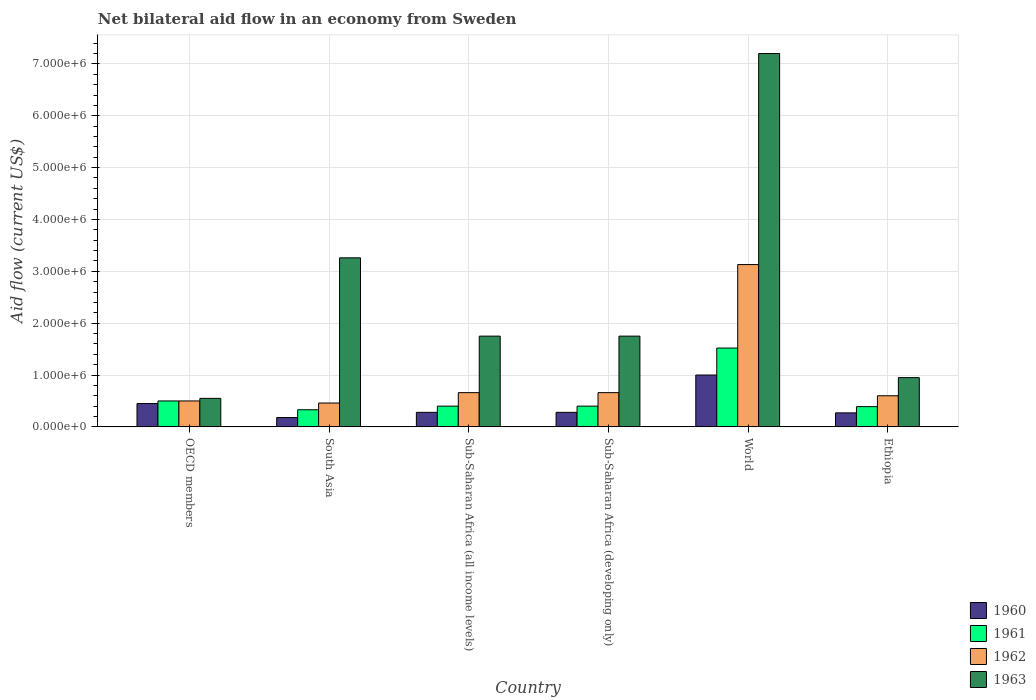How many different coloured bars are there?
Offer a very short reply. 4. How many groups of bars are there?
Your answer should be compact. 6. What is the label of the 6th group of bars from the left?
Offer a terse response. Ethiopia. In how many cases, is the number of bars for a given country not equal to the number of legend labels?
Provide a succinct answer. 0. Across all countries, what is the maximum net bilateral aid flow in 1961?
Your response must be concise. 1.52e+06. In which country was the net bilateral aid flow in 1961 maximum?
Your answer should be very brief. World. In which country was the net bilateral aid flow in 1963 minimum?
Make the answer very short. OECD members. What is the total net bilateral aid flow in 1962 in the graph?
Provide a succinct answer. 6.01e+06. What is the difference between the net bilateral aid flow in 1963 in Sub-Saharan Africa (all income levels) and that in World?
Offer a very short reply. -5.45e+06. What is the difference between the net bilateral aid flow in 1963 in Sub-Saharan Africa (developing only) and the net bilateral aid flow in 1962 in World?
Offer a terse response. -1.38e+06. What is the difference between the net bilateral aid flow of/in 1963 and net bilateral aid flow of/in 1961 in Sub-Saharan Africa (developing only)?
Your answer should be very brief. 1.35e+06. What is the ratio of the net bilateral aid flow in 1963 in OECD members to that in World?
Your answer should be compact. 0.08. Is the net bilateral aid flow in 1963 in Ethiopia less than that in Sub-Saharan Africa (developing only)?
Keep it short and to the point. Yes. What is the difference between the highest and the second highest net bilateral aid flow in 1963?
Give a very brief answer. 3.94e+06. What is the difference between the highest and the lowest net bilateral aid flow in 1962?
Your answer should be compact. 2.67e+06. In how many countries, is the net bilateral aid flow in 1963 greater than the average net bilateral aid flow in 1963 taken over all countries?
Offer a very short reply. 2. What is the difference between two consecutive major ticks on the Y-axis?
Your answer should be very brief. 1.00e+06. Does the graph contain any zero values?
Your response must be concise. No. Does the graph contain grids?
Offer a terse response. Yes. Where does the legend appear in the graph?
Keep it short and to the point. Bottom right. How are the legend labels stacked?
Keep it short and to the point. Vertical. What is the title of the graph?
Your answer should be compact. Net bilateral aid flow in an economy from Sweden. Does "1966" appear as one of the legend labels in the graph?
Offer a very short reply. No. What is the label or title of the X-axis?
Offer a terse response. Country. What is the label or title of the Y-axis?
Your answer should be compact. Aid flow (current US$). What is the Aid flow (current US$) in 1960 in OECD members?
Your answer should be compact. 4.50e+05. What is the Aid flow (current US$) of 1962 in OECD members?
Make the answer very short. 5.00e+05. What is the Aid flow (current US$) in 1962 in South Asia?
Your answer should be very brief. 4.60e+05. What is the Aid flow (current US$) in 1963 in South Asia?
Your response must be concise. 3.26e+06. What is the Aid flow (current US$) of 1961 in Sub-Saharan Africa (all income levels)?
Ensure brevity in your answer.  4.00e+05. What is the Aid flow (current US$) in 1962 in Sub-Saharan Africa (all income levels)?
Offer a terse response. 6.60e+05. What is the Aid flow (current US$) of 1963 in Sub-Saharan Africa (all income levels)?
Keep it short and to the point. 1.75e+06. What is the Aid flow (current US$) in 1960 in Sub-Saharan Africa (developing only)?
Offer a terse response. 2.80e+05. What is the Aid flow (current US$) in 1961 in Sub-Saharan Africa (developing only)?
Provide a succinct answer. 4.00e+05. What is the Aid flow (current US$) in 1963 in Sub-Saharan Africa (developing only)?
Provide a short and direct response. 1.75e+06. What is the Aid flow (current US$) of 1960 in World?
Your answer should be very brief. 1.00e+06. What is the Aid flow (current US$) in 1961 in World?
Provide a short and direct response. 1.52e+06. What is the Aid flow (current US$) in 1962 in World?
Give a very brief answer. 3.13e+06. What is the Aid flow (current US$) of 1963 in World?
Provide a succinct answer. 7.20e+06. What is the Aid flow (current US$) in 1963 in Ethiopia?
Make the answer very short. 9.50e+05. Across all countries, what is the maximum Aid flow (current US$) of 1961?
Keep it short and to the point. 1.52e+06. Across all countries, what is the maximum Aid flow (current US$) in 1962?
Provide a short and direct response. 3.13e+06. Across all countries, what is the maximum Aid flow (current US$) in 1963?
Your response must be concise. 7.20e+06. Across all countries, what is the minimum Aid flow (current US$) of 1960?
Keep it short and to the point. 1.80e+05. Across all countries, what is the minimum Aid flow (current US$) of 1961?
Offer a terse response. 3.30e+05. Across all countries, what is the minimum Aid flow (current US$) of 1962?
Provide a succinct answer. 4.60e+05. Across all countries, what is the minimum Aid flow (current US$) in 1963?
Your answer should be compact. 5.50e+05. What is the total Aid flow (current US$) in 1960 in the graph?
Make the answer very short. 2.46e+06. What is the total Aid flow (current US$) of 1961 in the graph?
Keep it short and to the point. 3.54e+06. What is the total Aid flow (current US$) in 1962 in the graph?
Make the answer very short. 6.01e+06. What is the total Aid flow (current US$) of 1963 in the graph?
Provide a short and direct response. 1.55e+07. What is the difference between the Aid flow (current US$) of 1960 in OECD members and that in South Asia?
Provide a short and direct response. 2.70e+05. What is the difference between the Aid flow (current US$) in 1961 in OECD members and that in South Asia?
Your response must be concise. 1.70e+05. What is the difference between the Aid flow (current US$) in 1962 in OECD members and that in South Asia?
Your answer should be very brief. 4.00e+04. What is the difference between the Aid flow (current US$) of 1963 in OECD members and that in South Asia?
Offer a terse response. -2.71e+06. What is the difference between the Aid flow (current US$) in 1960 in OECD members and that in Sub-Saharan Africa (all income levels)?
Offer a terse response. 1.70e+05. What is the difference between the Aid flow (current US$) of 1961 in OECD members and that in Sub-Saharan Africa (all income levels)?
Provide a succinct answer. 1.00e+05. What is the difference between the Aid flow (current US$) in 1963 in OECD members and that in Sub-Saharan Africa (all income levels)?
Provide a short and direct response. -1.20e+06. What is the difference between the Aid flow (current US$) in 1962 in OECD members and that in Sub-Saharan Africa (developing only)?
Offer a terse response. -1.60e+05. What is the difference between the Aid flow (current US$) in 1963 in OECD members and that in Sub-Saharan Africa (developing only)?
Give a very brief answer. -1.20e+06. What is the difference between the Aid flow (current US$) of 1960 in OECD members and that in World?
Make the answer very short. -5.50e+05. What is the difference between the Aid flow (current US$) of 1961 in OECD members and that in World?
Provide a short and direct response. -1.02e+06. What is the difference between the Aid flow (current US$) in 1962 in OECD members and that in World?
Ensure brevity in your answer.  -2.63e+06. What is the difference between the Aid flow (current US$) in 1963 in OECD members and that in World?
Provide a short and direct response. -6.65e+06. What is the difference between the Aid flow (current US$) in 1963 in OECD members and that in Ethiopia?
Your answer should be very brief. -4.00e+05. What is the difference between the Aid flow (current US$) of 1963 in South Asia and that in Sub-Saharan Africa (all income levels)?
Provide a succinct answer. 1.51e+06. What is the difference between the Aid flow (current US$) of 1962 in South Asia and that in Sub-Saharan Africa (developing only)?
Your answer should be compact. -2.00e+05. What is the difference between the Aid flow (current US$) of 1963 in South Asia and that in Sub-Saharan Africa (developing only)?
Your response must be concise. 1.51e+06. What is the difference between the Aid flow (current US$) in 1960 in South Asia and that in World?
Your answer should be very brief. -8.20e+05. What is the difference between the Aid flow (current US$) of 1961 in South Asia and that in World?
Provide a short and direct response. -1.19e+06. What is the difference between the Aid flow (current US$) in 1962 in South Asia and that in World?
Provide a short and direct response. -2.67e+06. What is the difference between the Aid flow (current US$) of 1963 in South Asia and that in World?
Provide a succinct answer. -3.94e+06. What is the difference between the Aid flow (current US$) of 1960 in South Asia and that in Ethiopia?
Make the answer very short. -9.00e+04. What is the difference between the Aid flow (current US$) in 1963 in South Asia and that in Ethiopia?
Your answer should be compact. 2.31e+06. What is the difference between the Aid flow (current US$) of 1960 in Sub-Saharan Africa (all income levels) and that in Sub-Saharan Africa (developing only)?
Your response must be concise. 0. What is the difference between the Aid flow (current US$) in 1960 in Sub-Saharan Africa (all income levels) and that in World?
Give a very brief answer. -7.20e+05. What is the difference between the Aid flow (current US$) of 1961 in Sub-Saharan Africa (all income levels) and that in World?
Your response must be concise. -1.12e+06. What is the difference between the Aid flow (current US$) in 1962 in Sub-Saharan Africa (all income levels) and that in World?
Your answer should be very brief. -2.47e+06. What is the difference between the Aid flow (current US$) of 1963 in Sub-Saharan Africa (all income levels) and that in World?
Give a very brief answer. -5.45e+06. What is the difference between the Aid flow (current US$) of 1962 in Sub-Saharan Africa (all income levels) and that in Ethiopia?
Offer a terse response. 6.00e+04. What is the difference between the Aid flow (current US$) of 1960 in Sub-Saharan Africa (developing only) and that in World?
Make the answer very short. -7.20e+05. What is the difference between the Aid flow (current US$) of 1961 in Sub-Saharan Africa (developing only) and that in World?
Your answer should be very brief. -1.12e+06. What is the difference between the Aid flow (current US$) of 1962 in Sub-Saharan Africa (developing only) and that in World?
Offer a very short reply. -2.47e+06. What is the difference between the Aid flow (current US$) in 1963 in Sub-Saharan Africa (developing only) and that in World?
Give a very brief answer. -5.45e+06. What is the difference between the Aid flow (current US$) of 1960 in Sub-Saharan Africa (developing only) and that in Ethiopia?
Offer a terse response. 10000. What is the difference between the Aid flow (current US$) in 1961 in Sub-Saharan Africa (developing only) and that in Ethiopia?
Give a very brief answer. 10000. What is the difference between the Aid flow (current US$) of 1962 in Sub-Saharan Africa (developing only) and that in Ethiopia?
Provide a short and direct response. 6.00e+04. What is the difference between the Aid flow (current US$) of 1960 in World and that in Ethiopia?
Provide a short and direct response. 7.30e+05. What is the difference between the Aid flow (current US$) in 1961 in World and that in Ethiopia?
Keep it short and to the point. 1.13e+06. What is the difference between the Aid flow (current US$) of 1962 in World and that in Ethiopia?
Ensure brevity in your answer.  2.53e+06. What is the difference between the Aid flow (current US$) in 1963 in World and that in Ethiopia?
Give a very brief answer. 6.25e+06. What is the difference between the Aid flow (current US$) of 1960 in OECD members and the Aid flow (current US$) of 1963 in South Asia?
Your answer should be compact. -2.81e+06. What is the difference between the Aid flow (current US$) of 1961 in OECD members and the Aid flow (current US$) of 1963 in South Asia?
Keep it short and to the point. -2.76e+06. What is the difference between the Aid flow (current US$) in 1962 in OECD members and the Aid flow (current US$) in 1963 in South Asia?
Make the answer very short. -2.76e+06. What is the difference between the Aid flow (current US$) of 1960 in OECD members and the Aid flow (current US$) of 1963 in Sub-Saharan Africa (all income levels)?
Your answer should be compact. -1.30e+06. What is the difference between the Aid flow (current US$) in 1961 in OECD members and the Aid flow (current US$) in 1963 in Sub-Saharan Africa (all income levels)?
Keep it short and to the point. -1.25e+06. What is the difference between the Aid flow (current US$) in 1962 in OECD members and the Aid flow (current US$) in 1963 in Sub-Saharan Africa (all income levels)?
Give a very brief answer. -1.25e+06. What is the difference between the Aid flow (current US$) in 1960 in OECD members and the Aid flow (current US$) in 1961 in Sub-Saharan Africa (developing only)?
Make the answer very short. 5.00e+04. What is the difference between the Aid flow (current US$) of 1960 in OECD members and the Aid flow (current US$) of 1962 in Sub-Saharan Africa (developing only)?
Give a very brief answer. -2.10e+05. What is the difference between the Aid flow (current US$) of 1960 in OECD members and the Aid flow (current US$) of 1963 in Sub-Saharan Africa (developing only)?
Your response must be concise. -1.30e+06. What is the difference between the Aid flow (current US$) of 1961 in OECD members and the Aid flow (current US$) of 1963 in Sub-Saharan Africa (developing only)?
Your answer should be very brief. -1.25e+06. What is the difference between the Aid flow (current US$) of 1962 in OECD members and the Aid flow (current US$) of 1963 in Sub-Saharan Africa (developing only)?
Give a very brief answer. -1.25e+06. What is the difference between the Aid flow (current US$) in 1960 in OECD members and the Aid flow (current US$) in 1961 in World?
Offer a terse response. -1.07e+06. What is the difference between the Aid flow (current US$) of 1960 in OECD members and the Aid flow (current US$) of 1962 in World?
Provide a short and direct response. -2.68e+06. What is the difference between the Aid flow (current US$) of 1960 in OECD members and the Aid flow (current US$) of 1963 in World?
Keep it short and to the point. -6.75e+06. What is the difference between the Aid flow (current US$) of 1961 in OECD members and the Aid flow (current US$) of 1962 in World?
Give a very brief answer. -2.63e+06. What is the difference between the Aid flow (current US$) of 1961 in OECD members and the Aid flow (current US$) of 1963 in World?
Your answer should be compact. -6.70e+06. What is the difference between the Aid flow (current US$) in 1962 in OECD members and the Aid flow (current US$) in 1963 in World?
Make the answer very short. -6.70e+06. What is the difference between the Aid flow (current US$) in 1960 in OECD members and the Aid flow (current US$) in 1962 in Ethiopia?
Make the answer very short. -1.50e+05. What is the difference between the Aid flow (current US$) in 1960 in OECD members and the Aid flow (current US$) in 1963 in Ethiopia?
Provide a succinct answer. -5.00e+05. What is the difference between the Aid flow (current US$) of 1961 in OECD members and the Aid flow (current US$) of 1963 in Ethiopia?
Offer a very short reply. -4.50e+05. What is the difference between the Aid flow (current US$) of 1962 in OECD members and the Aid flow (current US$) of 1963 in Ethiopia?
Keep it short and to the point. -4.50e+05. What is the difference between the Aid flow (current US$) of 1960 in South Asia and the Aid flow (current US$) of 1962 in Sub-Saharan Africa (all income levels)?
Your answer should be compact. -4.80e+05. What is the difference between the Aid flow (current US$) in 1960 in South Asia and the Aid flow (current US$) in 1963 in Sub-Saharan Africa (all income levels)?
Offer a very short reply. -1.57e+06. What is the difference between the Aid flow (current US$) of 1961 in South Asia and the Aid flow (current US$) of 1962 in Sub-Saharan Africa (all income levels)?
Ensure brevity in your answer.  -3.30e+05. What is the difference between the Aid flow (current US$) of 1961 in South Asia and the Aid flow (current US$) of 1963 in Sub-Saharan Africa (all income levels)?
Make the answer very short. -1.42e+06. What is the difference between the Aid flow (current US$) of 1962 in South Asia and the Aid flow (current US$) of 1963 in Sub-Saharan Africa (all income levels)?
Provide a succinct answer. -1.29e+06. What is the difference between the Aid flow (current US$) in 1960 in South Asia and the Aid flow (current US$) in 1961 in Sub-Saharan Africa (developing only)?
Make the answer very short. -2.20e+05. What is the difference between the Aid flow (current US$) of 1960 in South Asia and the Aid flow (current US$) of 1962 in Sub-Saharan Africa (developing only)?
Make the answer very short. -4.80e+05. What is the difference between the Aid flow (current US$) of 1960 in South Asia and the Aid flow (current US$) of 1963 in Sub-Saharan Africa (developing only)?
Offer a very short reply. -1.57e+06. What is the difference between the Aid flow (current US$) in 1961 in South Asia and the Aid flow (current US$) in 1962 in Sub-Saharan Africa (developing only)?
Your response must be concise. -3.30e+05. What is the difference between the Aid flow (current US$) of 1961 in South Asia and the Aid flow (current US$) of 1963 in Sub-Saharan Africa (developing only)?
Offer a terse response. -1.42e+06. What is the difference between the Aid flow (current US$) in 1962 in South Asia and the Aid flow (current US$) in 1963 in Sub-Saharan Africa (developing only)?
Ensure brevity in your answer.  -1.29e+06. What is the difference between the Aid flow (current US$) in 1960 in South Asia and the Aid flow (current US$) in 1961 in World?
Your answer should be very brief. -1.34e+06. What is the difference between the Aid flow (current US$) in 1960 in South Asia and the Aid flow (current US$) in 1962 in World?
Keep it short and to the point. -2.95e+06. What is the difference between the Aid flow (current US$) in 1960 in South Asia and the Aid flow (current US$) in 1963 in World?
Provide a short and direct response. -7.02e+06. What is the difference between the Aid flow (current US$) of 1961 in South Asia and the Aid flow (current US$) of 1962 in World?
Offer a very short reply. -2.80e+06. What is the difference between the Aid flow (current US$) of 1961 in South Asia and the Aid flow (current US$) of 1963 in World?
Make the answer very short. -6.87e+06. What is the difference between the Aid flow (current US$) of 1962 in South Asia and the Aid flow (current US$) of 1963 in World?
Provide a short and direct response. -6.74e+06. What is the difference between the Aid flow (current US$) of 1960 in South Asia and the Aid flow (current US$) of 1962 in Ethiopia?
Provide a short and direct response. -4.20e+05. What is the difference between the Aid flow (current US$) in 1960 in South Asia and the Aid flow (current US$) in 1963 in Ethiopia?
Make the answer very short. -7.70e+05. What is the difference between the Aid flow (current US$) of 1961 in South Asia and the Aid flow (current US$) of 1962 in Ethiopia?
Keep it short and to the point. -2.70e+05. What is the difference between the Aid flow (current US$) in 1961 in South Asia and the Aid flow (current US$) in 1963 in Ethiopia?
Keep it short and to the point. -6.20e+05. What is the difference between the Aid flow (current US$) of 1962 in South Asia and the Aid flow (current US$) of 1963 in Ethiopia?
Your answer should be compact. -4.90e+05. What is the difference between the Aid flow (current US$) in 1960 in Sub-Saharan Africa (all income levels) and the Aid flow (current US$) in 1961 in Sub-Saharan Africa (developing only)?
Offer a very short reply. -1.20e+05. What is the difference between the Aid flow (current US$) of 1960 in Sub-Saharan Africa (all income levels) and the Aid flow (current US$) of 1962 in Sub-Saharan Africa (developing only)?
Keep it short and to the point. -3.80e+05. What is the difference between the Aid flow (current US$) in 1960 in Sub-Saharan Africa (all income levels) and the Aid flow (current US$) in 1963 in Sub-Saharan Africa (developing only)?
Provide a short and direct response. -1.47e+06. What is the difference between the Aid flow (current US$) in 1961 in Sub-Saharan Africa (all income levels) and the Aid flow (current US$) in 1963 in Sub-Saharan Africa (developing only)?
Keep it short and to the point. -1.35e+06. What is the difference between the Aid flow (current US$) of 1962 in Sub-Saharan Africa (all income levels) and the Aid flow (current US$) of 1963 in Sub-Saharan Africa (developing only)?
Ensure brevity in your answer.  -1.09e+06. What is the difference between the Aid flow (current US$) in 1960 in Sub-Saharan Africa (all income levels) and the Aid flow (current US$) in 1961 in World?
Offer a very short reply. -1.24e+06. What is the difference between the Aid flow (current US$) of 1960 in Sub-Saharan Africa (all income levels) and the Aid flow (current US$) of 1962 in World?
Offer a very short reply. -2.85e+06. What is the difference between the Aid flow (current US$) in 1960 in Sub-Saharan Africa (all income levels) and the Aid flow (current US$) in 1963 in World?
Your answer should be very brief. -6.92e+06. What is the difference between the Aid flow (current US$) in 1961 in Sub-Saharan Africa (all income levels) and the Aid flow (current US$) in 1962 in World?
Your response must be concise. -2.73e+06. What is the difference between the Aid flow (current US$) in 1961 in Sub-Saharan Africa (all income levels) and the Aid flow (current US$) in 1963 in World?
Keep it short and to the point. -6.80e+06. What is the difference between the Aid flow (current US$) of 1962 in Sub-Saharan Africa (all income levels) and the Aid flow (current US$) of 1963 in World?
Ensure brevity in your answer.  -6.54e+06. What is the difference between the Aid flow (current US$) in 1960 in Sub-Saharan Africa (all income levels) and the Aid flow (current US$) in 1961 in Ethiopia?
Keep it short and to the point. -1.10e+05. What is the difference between the Aid flow (current US$) in 1960 in Sub-Saharan Africa (all income levels) and the Aid flow (current US$) in 1962 in Ethiopia?
Make the answer very short. -3.20e+05. What is the difference between the Aid flow (current US$) in 1960 in Sub-Saharan Africa (all income levels) and the Aid flow (current US$) in 1963 in Ethiopia?
Your response must be concise. -6.70e+05. What is the difference between the Aid flow (current US$) in 1961 in Sub-Saharan Africa (all income levels) and the Aid flow (current US$) in 1962 in Ethiopia?
Your answer should be very brief. -2.00e+05. What is the difference between the Aid flow (current US$) of 1961 in Sub-Saharan Africa (all income levels) and the Aid flow (current US$) of 1963 in Ethiopia?
Your response must be concise. -5.50e+05. What is the difference between the Aid flow (current US$) of 1960 in Sub-Saharan Africa (developing only) and the Aid flow (current US$) of 1961 in World?
Your answer should be very brief. -1.24e+06. What is the difference between the Aid flow (current US$) of 1960 in Sub-Saharan Africa (developing only) and the Aid flow (current US$) of 1962 in World?
Provide a succinct answer. -2.85e+06. What is the difference between the Aid flow (current US$) of 1960 in Sub-Saharan Africa (developing only) and the Aid flow (current US$) of 1963 in World?
Your answer should be very brief. -6.92e+06. What is the difference between the Aid flow (current US$) in 1961 in Sub-Saharan Africa (developing only) and the Aid flow (current US$) in 1962 in World?
Your answer should be compact. -2.73e+06. What is the difference between the Aid flow (current US$) of 1961 in Sub-Saharan Africa (developing only) and the Aid flow (current US$) of 1963 in World?
Your answer should be compact. -6.80e+06. What is the difference between the Aid flow (current US$) in 1962 in Sub-Saharan Africa (developing only) and the Aid flow (current US$) in 1963 in World?
Make the answer very short. -6.54e+06. What is the difference between the Aid flow (current US$) of 1960 in Sub-Saharan Africa (developing only) and the Aid flow (current US$) of 1961 in Ethiopia?
Your response must be concise. -1.10e+05. What is the difference between the Aid flow (current US$) of 1960 in Sub-Saharan Africa (developing only) and the Aid flow (current US$) of 1962 in Ethiopia?
Provide a succinct answer. -3.20e+05. What is the difference between the Aid flow (current US$) of 1960 in Sub-Saharan Africa (developing only) and the Aid flow (current US$) of 1963 in Ethiopia?
Ensure brevity in your answer.  -6.70e+05. What is the difference between the Aid flow (current US$) of 1961 in Sub-Saharan Africa (developing only) and the Aid flow (current US$) of 1963 in Ethiopia?
Provide a short and direct response. -5.50e+05. What is the difference between the Aid flow (current US$) of 1960 in World and the Aid flow (current US$) of 1961 in Ethiopia?
Your answer should be compact. 6.10e+05. What is the difference between the Aid flow (current US$) of 1960 in World and the Aid flow (current US$) of 1962 in Ethiopia?
Make the answer very short. 4.00e+05. What is the difference between the Aid flow (current US$) in 1961 in World and the Aid flow (current US$) in 1962 in Ethiopia?
Offer a very short reply. 9.20e+05. What is the difference between the Aid flow (current US$) in 1961 in World and the Aid flow (current US$) in 1963 in Ethiopia?
Your answer should be compact. 5.70e+05. What is the difference between the Aid flow (current US$) in 1962 in World and the Aid flow (current US$) in 1963 in Ethiopia?
Your answer should be compact. 2.18e+06. What is the average Aid flow (current US$) in 1961 per country?
Provide a short and direct response. 5.90e+05. What is the average Aid flow (current US$) of 1962 per country?
Ensure brevity in your answer.  1.00e+06. What is the average Aid flow (current US$) of 1963 per country?
Give a very brief answer. 2.58e+06. What is the difference between the Aid flow (current US$) in 1960 and Aid flow (current US$) in 1963 in OECD members?
Your response must be concise. -1.00e+05. What is the difference between the Aid flow (current US$) in 1961 and Aid flow (current US$) in 1963 in OECD members?
Provide a succinct answer. -5.00e+04. What is the difference between the Aid flow (current US$) of 1962 and Aid flow (current US$) of 1963 in OECD members?
Your response must be concise. -5.00e+04. What is the difference between the Aid flow (current US$) in 1960 and Aid flow (current US$) in 1961 in South Asia?
Provide a short and direct response. -1.50e+05. What is the difference between the Aid flow (current US$) in 1960 and Aid flow (current US$) in 1962 in South Asia?
Your answer should be very brief. -2.80e+05. What is the difference between the Aid flow (current US$) in 1960 and Aid flow (current US$) in 1963 in South Asia?
Provide a succinct answer. -3.08e+06. What is the difference between the Aid flow (current US$) in 1961 and Aid flow (current US$) in 1962 in South Asia?
Ensure brevity in your answer.  -1.30e+05. What is the difference between the Aid flow (current US$) in 1961 and Aid flow (current US$) in 1963 in South Asia?
Your answer should be very brief. -2.93e+06. What is the difference between the Aid flow (current US$) of 1962 and Aid flow (current US$) of 1963 in South Asia?
Offer a terse response. -2.80e+06. What is the difference between the Aid flow (current US$) of 1960 and Aid flow (current US$) of 1962 in Sub-Saharan Africa (all income levels)?
Your response must be concise. -3.80e+05. What is the difference between the Aid flow (current US$) of 1960 and Aid flow (current US$) of 1963 in Sub-Saharan Africa (all income levels)?
Provide a succinct answer. -1.47e+06. What is the difference between the Aid flow (current US$) of 1961 and Aid flow (current US$) of 1962 in Sub-Saharan Africa (all income levels)?
Make the answer very short. -2.60e+05. What is the difference between the Aid flow (current US$) of 1961 and Aid flow (current US$) of 1963 in Sub-Saharan Africa (all income levels)?
Ensure brevity in your answer.  -1.35e+06. What is the difference between the Aid flow (current US$) of 1962 and Aid flow (current US$) of 1963 in Sub-Saharan Africa (all income levels)?
Keep it short and to the point. -1.09e+06. What is the difference between the Aid flow (current US$) in 1960 and Aid flow (current US$) in 1962 in Sub-Saharan Africa (developing only)?
Your answer should be very brief. -3.80e+05. What is the difference between the Aid flow (current US$) of 1960 and Aid flow (current US$) of 1963 in Sub-Saharan Africa (developing only)?
Offer a very short reply. -1.47e+06. What is the difference between the Aid flow (current US$) in 1961 and Aid flow (current US$) in 1962 in Sub-Saharan Africa (developing only)?
Give a very brief answer. -2.60e+05. What is the difference between the Aid flow (current US$) in 1961 and Aid flow (current US$) in 1963 in Sub-Saharan Africa (developing only)?
Keep it short and to the point. -1.35e+06. What is the difference between the Aid flow (current US$) of 1962 and Aid flow (current US$) of 1963 in Sub-Saharan Africa (developing only)?
Make the answer very short. -1.09e+06. What is the difference between the Aid flow (current US$) of 1960 and Aid flow (current US$) of 1961 in World?
Your answer should be compact. -5.20e+05. What is the difference between the Aid flow (current US$) of 1960 and Aid flow (current US$) of 1962 in World?
Offer a very short reply. -2.13e+06. What is the difference between the Aid flow (current US$) of 1960 and Aid flow (current US$) of 1963 in World?
Offer a very short reply. -6.20e+06. What is the difference between the Aid flow (current US$) of 1961 and Aid flow (current US$) of 1962 in World?
Provide a short and direct response. -1.61e+06. What is the difference between the Aid flow (current US$) in 1961 and Aid flow (current US$) in 1963 in World?
Provide a short and direct response. -5.68e+06. What is the difference between the Aid flow (current US$) of 1962 and Aid flow (current US$) of 1963 in World?
Your answer should be very brief. -4.07e+06. What is the difference between the Aid flow (current US$) of 1960 and Aid flow (current US$) of 1961 in Ethiopia?
Your response must be concise. -1.20e+05. What is the difference between the Aid flow (current US$) of 1960 and Aid flow (current US$) of 1962 in Ethiopia?
Offer a very short reply. -3.30e+05. What is the difference between the Aid flow (current US$) of 1960 and Aid flow (current US$) of 1963 in Ethiopia?
Your response must be concise. -6.80e+05. What is the difference between the Aid flow (current US$) of 1961 and Aid flow (current US$) of 1962 in Ethiopia?
Keep it short and to the point. -2.10e+05. What is the difference between the Aid flow (current US$) in 1961 and Aid flow (current US$) in 1963 in Ethiopia?
Ensure brevity in your answer.  -5.60e+05. What is the difference between the Aid flow (current US$) in 1962 and Aid flow (current US$) in 1963 in Ethiopia?
Give a very brief answer. -3.50e+05. What is the ratio of the Aid flow (current US$) of 1961 in OECD members to that in South Asia?
Provide a succinct answer. 1.52. What is the ratio of the Aid flow (current US$) in 1962 in OECD members to that in South Asia?
Offer a very short reply. 1.09. What is the ratio of the Aid flow (current US$) of 1963 in OECD members to that in South Asia?
Give a very brief answer. 0.17. What is the ratio of the Aid flow (current US$) in 1960 in OECD members to that in Sub-Saharan Africa (all income levels)?
Ensure brevity in your answer.  1.61. What is the ratio of the Aid flow (current US$) in 1962 in OECD members to that in Sub-Saharan Africa (all income levels)?
Provide a short and direct response. 0.76. What is the ratio of the Aid flow (current US$) in 1963 in OECD members to that in Sub-Saharan Africa (all income levels)?
Offer a terse response. 0.31. What is the ratio of the Aid flow (current US$) in 1960 in OECD members to that in Sub-Saharan Africa (developing only)?
Make the answer very short. 1.61. What is the ratio of the Aid flow (current US$) in 1962 in OECD members to that in Sub-Saharan Africa (developing only)?
Provide a succinct answer. 0.76. What is the ratio of the Aid flow (current US$) of 1963 in OECD members to that in Sub-Saharan Africa (developing only)?
Your answer should be compact. 0.31. What is the ratio of the Aid flow (current US$) in 1960 in OECD members to that in World?
Offer a terse response. 0.45. What is the ratio of the Aid flow (current US$) of 1961 in OECD members to that in World?
Keep it short and to the point. 0.33. What is the ratio of the Aid flow (current US$) in 1962 in OECD members to that in World?
Make the answer very short. 0.16. What is the ratio of the Aid flow (current US$) of 1963 in OECD members to that in World?
Keep it short and to the point. 0.08. What is the ratio of the Aid flow (current US$) in 1961 in OECD members to that in Ethiopia?
Keep it short and to the point. 1.28. What is the ratio of the Aid flow (current US$) of 1962 in OECD members to that in Ethiopia?
Offer a terse response. 0.83. What is the ratio of the Aid flow (current US$) of 1963 in OECD members to that in Ethiopia?
Your answer should be very brief. 0.58. What is the ratio of the Aid flow (current US$) of 1960 in South Asia to that in Sub-Saharan Africa (all income levels)?
Provide a succinct answer. 0.64. What is the ratio of the Aid flow (current US$) in 1961 in South Asia to that in Sub-Saharan Africa (all income levels)?
Make the answer very short. 0.82. What is the ratio of the Aid flow (current US$) of 1962 in South Asia to that in Sub-Saharan Africa (all income levels)?
Your answer should be very brief. 0.7. What is the ratio of the Aid flow (current US$) of 1963 in South Asia to that in Sub-Saharan Africa (all income levels)?
Provide a short and direct response. 1.86. What is the ratio of the Aid flow (current US$) in 1960 in South Asia to that in Sub-Saharan Africa (developing only)?
Provide a succinct answer. 0.64. What is the ratio of the Aid flow (current US$) in 1961 in South Asia to that in Sub-Saharan Africa (developing only)?
Provide a short and direct response. 0.82. What is the ratio of the Aid flow (current US$) in 1962 in South Asia to that in Sub-Saharan Africa (developing only)?
Give a very brief answer. 0.7. What is the ratio of the Aid flow (current US$) in 1963 in South Asia to that in Sub-Saharan Africa (developing only)?
Offer a very short reply. 1.86. What is the ratio of the Aid flow (current US$) of 1960 in South Asia to that in World?
Your answer should be very brief. 0.18. What is the ratio of the Aid flow (current US$) in 1961 in South Asia to that in World?
Offer a terse response. 0.22. What is the ratio of the Aid flow (current US$) in 1962 in South Asia to that in World?
Ensure brevity in your answer.  0.15. What is the ratio of the Aid flow (current US$) of 1963 in South Asia to that in World?
Your answer should be very brief. 0.45. What is the ratio of the Aid flow (current US$) of 1960 in South Asia to that in Ethiopia?
Provide a short and direct response. 0.67. What is the ratio of the Aid flow (current US$) in 1961 in South Asia to that in Ethiopia?
Offer a very short reply. 0.85. What is the ratio of the Aid flow (current US$) of 1962 in South Asia to that in Ethiopia?
Your answer should be very brief. 0.77. What is the ratio of the Aid flow (current US$) of 1963 in South Asia to that in Ethiopia?
Your answer should be very brief. 3.43. What is the ratio of the Aid flow (current US$) of 1960 in Sub-Saharan Africa (all income levels) to that in Sub-Saharan Africa (developing only)?
Make the answer very short. 1. What is the ratio of the Aid flow (current US$) of 1963 in Sub-Saharan Africa (all income levels) to that in Sub-Saharan Africa (developing only)?
Give a very brief answer. 1. What is the ratio of the Aid flow (current US$) in 1960 in Sub-Saharan Africa (all income levels) to that in World?
Your answer should be compact. 0.28. What is the ratio of the Aid flow (current US$) in 1961 in Sub-Saharan Africa (all income levels) to that in World?
Keep it short and to the point. 0.26. What is the ratio of the Aid flow (current US$) in 1962 in Sub-Saharan Africa (all income levels) to that in World?
Make the answer very short. 0.21. What is the ratio of the Aid flow (current US$) of 1963 in Sub-Saharan Africa (all income levels) to that in World?
Make the answer very short. 0.24. What is the ratio of the Aid flow (current US$) in 1961 in Sub-Saharan Africa (all income levels) to that in Ethiopia?
Offer a terse response. 1.03. What is the ratio of the Aid flow (current US$) in 1962 in Sub-Saharan Africa (all income levels) to that in Ethiopia?
Offer a very short reply. 1.1. What is the ratio of the Aid flow (current US$) in 1963 in Sub-Saharan Africa (all income levels) to that in Ethiopia?
Offer a terse response. 1.84. What is the ratio of the Aid flow (current US$) of 1960 in Sub-Saharan Africa (developing only) to that in World?
Your answer should be compact. 0.28. What is the ratio of the Aid flow (current US$) of 1961 in Sub-Saharan Africa (developing only) to that in World?
Your answer should be compact. 0.26. What is the ratio of the Aid flow (current US$) of 1962 in Sub-Saharan Africa (developing only) to that in World?
Provide a succinct answer. 0.21. What is the ratio of the Aid flow (current US$) in 1963 in Sub-Saharan Africa (developing only) to that in World?
Your answer should be very brief. 0.24. What is the ratio of the Aid flow (current US$) of 1961 in Sub-Saharan Africa (developing only) to that in Ethiopia?
Your response must be concise. 1.03. What is the ratio of the Aid flow (current US$) of 1962 in Sub-Saharan Africa (developing only) to that in Ethiopia?
Offer a very short reply. 1.1. What is the ratio of the Aid flow (current US$) in 1963 in Sub-Saharan Africa (developing only) to that in Ethiopia?
Give a very brief answer. 1.84. What is the ratio of the Aid flow (current US$) of 1960 in World to that in Ethiopia?
Provide a succinct answer. 3.7. What is the ratio of the Aid flow (current US$) of 1961 in World to that in Ethiopia?
Your response must be concise. 3.9. What is the ratio of the Aid flow (current US$) of 1962 in World to that in Ethiopia?
Your answer should be compact. 5.22. What is the ratio of the Aid flow (current US$) in 1963 in World to that in Ethiopia?
Your response must be concise. 7.58. What is the difference between the highest and the second highest Aid flow (current US$) in 1960?
Offer a terse response. 5.50e+05. What is the difference between the highest and the second highest Aid flow (current US$) of 1961?
Offer a terse response. 1.02e+06. What is the difference between the highest and the second highest Aid flow (current US$) of 1962?
Offer a terse response. 2.47e+06. What is the difference between the highest and the second highest Aid flow (current US$) in 1963?
Your answer should be compact. 3.94e+06. What is the difference between the highest and the lowest Aid flow (current US$) in 1960?
Make the answer very short. 8.20e+05. What is the difference between the highest and the lowest Aid flow (current US$) of 1961?
Make the answer very short. 1.19e+06. What is the difference between the highest and the lowest Aid flow (current US$) of 1962?
Offer a very short reply. 2.67e+06. What is the difference between the highest and the lowest Aid flow (current US$) in 1963?
Offer a very short reply. 6.65e+06. 